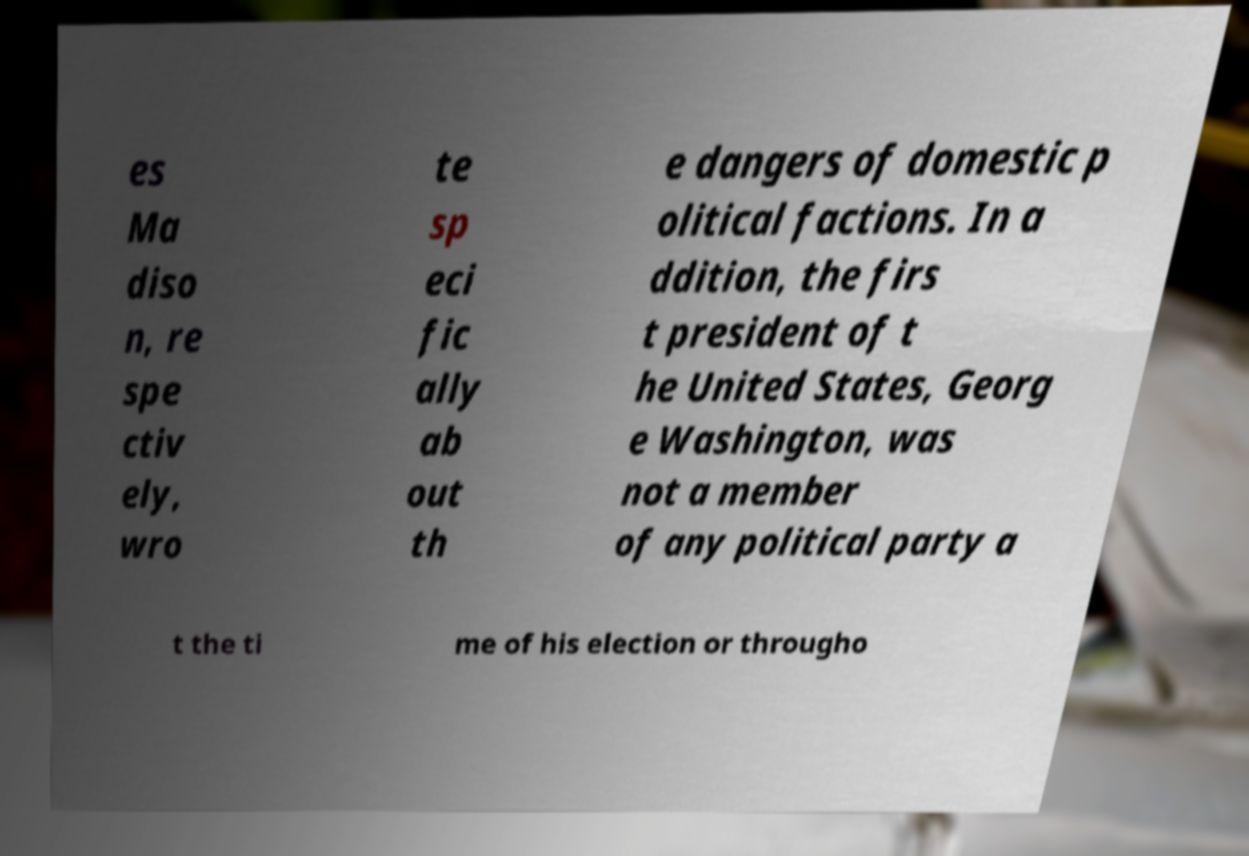Please identify and transcribe the text found in this image. es Ma diso n, re spe ctiv ely, wro te sp eci fic ally ab out th e dangers of domestic p olitical factions. In a ddition, the firs t president of t he United States, Georg e Washington, was not a member of any political party a t the ti me of his election or througho 